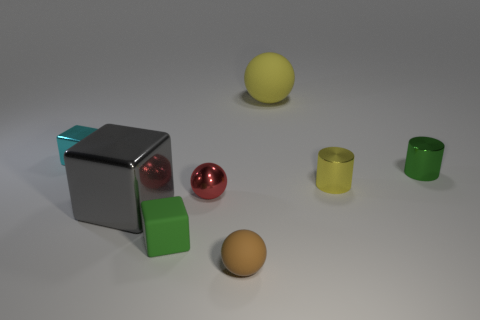Subtract all large spheres. How many spheres are left? 2 Add 1 big metal blocks. How many objects exist? 9 Subtract all yellow cylinders. How many cylinders are left? 1 Subtract 2 balls. How many balls are left? 1 Add 3 cyan shiny objects. How many cyan shiny objects are left? 4 Add 8 brown matte spheres. How many brown matte spheres exist? 9 Subtract 0 blue blocks. How many objects are left? 8 Subtract all blocks. How many objects are left? 5 Subtract all brown cylinders. Subtract all gray spheres. How many cylinders are left? 2 Subtract all big red cylinders. Subtract all big yellow rubber balls. How many objects are left? 7 